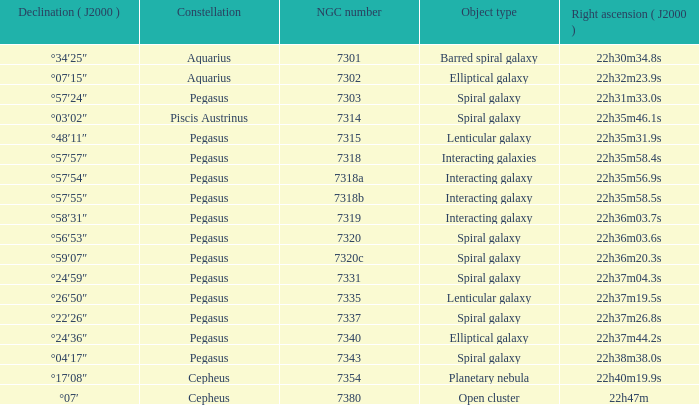What is the declination of the spiral galaxy Pegasus with 7337 NGC °22′26″. Could you parse the entire table as a dict? {'header': ['Declination ( J2000 )', 'Constellation', 'NGC number', 'Object type', 'Right ascension ( J2000 )'], 'rows': [['°34′25″', 'Aquarius', '7301', 'Barred spiral galaxy', '22h30m34.8s'], ['°07′15″', 'Aquarius', '7302', 'Elliptical galaxy', '22h32m23.9s'], ['°57′24″', 'Pegasus', '7303', 'Spiral galaxy', '22h31m33.0s'], ['°03′02″', 'Piscis Austrinus', '7314', 'Spiral galaxy', '22h35m46.1s'], ['°48′11″', 'Pegasus', '7315', 'Lenticular galaxy', '22h35m31.9s'], ['°57′57″', 'Pegasus', '7318', 'Interacting galaxies', '22h35m58.4s'], ['°57′54″', 'Pegasus', '7318a', 'Interacting galaxy', '22h35m56.9s'], ['°57′55″', 'Pegasus', '7318b', 'Interacting galaxy', '22h35m58.5s'], ['°58′31″', 'Pegasus', '7319', 'Interacting galaxy', '22h36m03.7s'], ['°56′53″', 'Pegasus', '7320', 'Spiral galaxy', '22h36m03.6s'], ['°59′07″', 'Pegasus', '7320c', 'Spiral galaxy', '22h36m20.3s'], ['°24′59″', 'Pegasus', '7331', 'Spiral galaxy', '22h37m04.3s'], ['°26′50″', 'Pegasus', '7335', 'Lenticular galaxy', '22h37m19.5s'], ['°22′26″', 'Pegasus', '7337', 'Spiral galaxy', '22h37m26.8s'], ['°24′36″', 'Pegasus', '7340', 'Elliptical galaxy', '22h37m44.2s'], ['°04′17″', 'Pegasus', '7343', 'Spiral galaxy', '22h38m38.0s'], ['°17′08″', 'Cepheus', '7354', 'Planetary nebula', '22h40m19.9s'], ['°07′', 'Cepheus', '7380', 'Open cluster', '22h47m']]} 